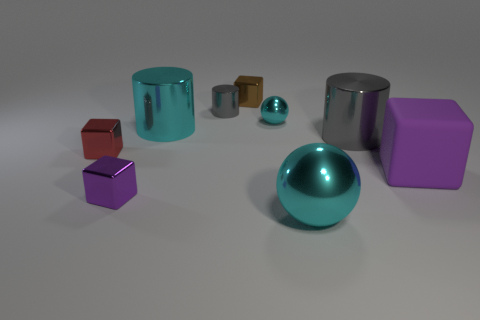Subtract all red shiny blocks. How many blocks are left? 3 Subtract all brown blocks. How many blocks are left? 3 Subtract all balls. How many objects are left? 7 Add 2 tiny blocks. How many tiny blocks are left? 5 Add 8 red metallic things. How many red metallic things exist? 9 Subtract 0 green cylinders. How many objects are left? 9 Subtract 3 cubes. How many cubes are left? 1 Subtract all green cylinders. Subtract all brown cubes. How many cylinders are left? 3 Subtract all gray balls. How many gray cylinders are left? 2 Subtract all large red cubes. Subtract all tiny red shiny cubes. How many objects are left? 8 